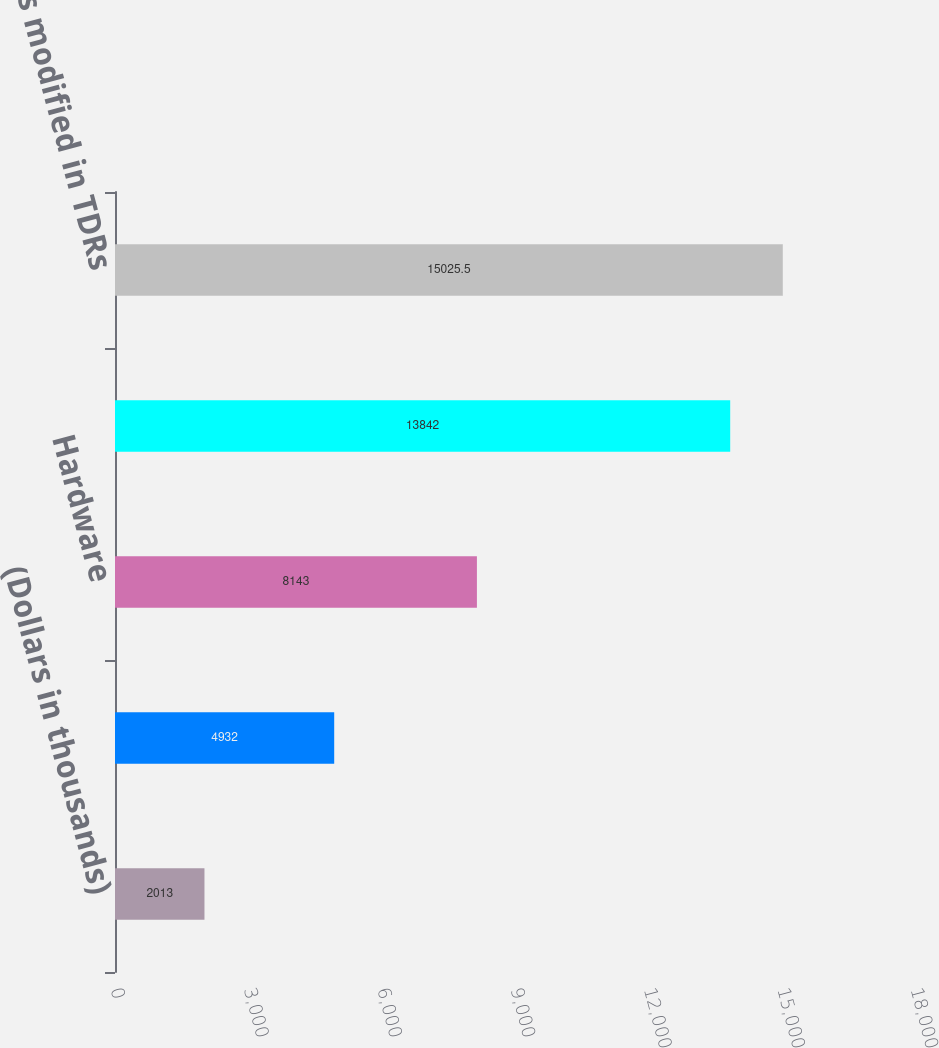Convert chart. <chart><loc_0><loc_0><loc_500><loc_500><bar_chart><fcel>(Dollars in thousands)<fcel>Software and internet<fcel>Hardware<fcel>Total commercial loans<fcel>Total loans modified in TDRs<nl><fcel>2013<fcel>4932<fcel>8143<fcel>13842<fcel>15025.5<nl></chart> 